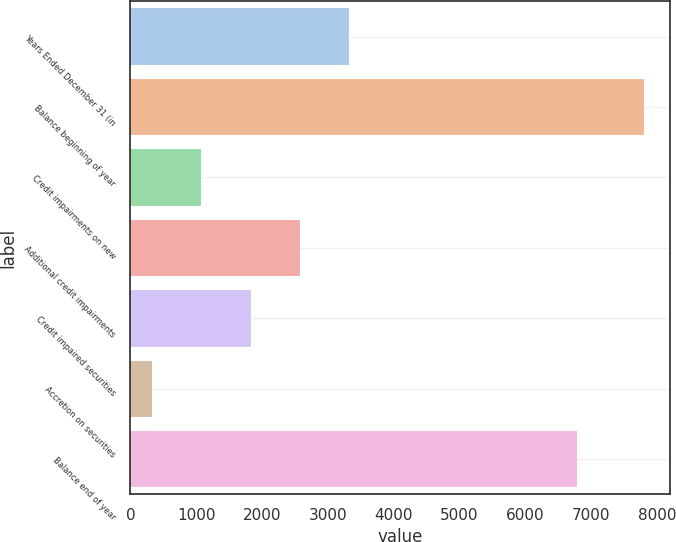Convert chart. <chart><loc_0><loc_0><loc_500><loc_500><bar_chart><fcel>Years Ended December 31 (in<fcel>Balance beginning of year<fcel>Credit impairments on new<fcel>Additional credit impairments<fcel>Credit impaired securities<fcel>Accretion on securities<fcel>Balance end of year<nl><fcel>3320.4<fcel>7803<fcel>1079.1<fcel>2573.3<fcel>1826.2<fcel>332<fcel>6786<nl></chart> 